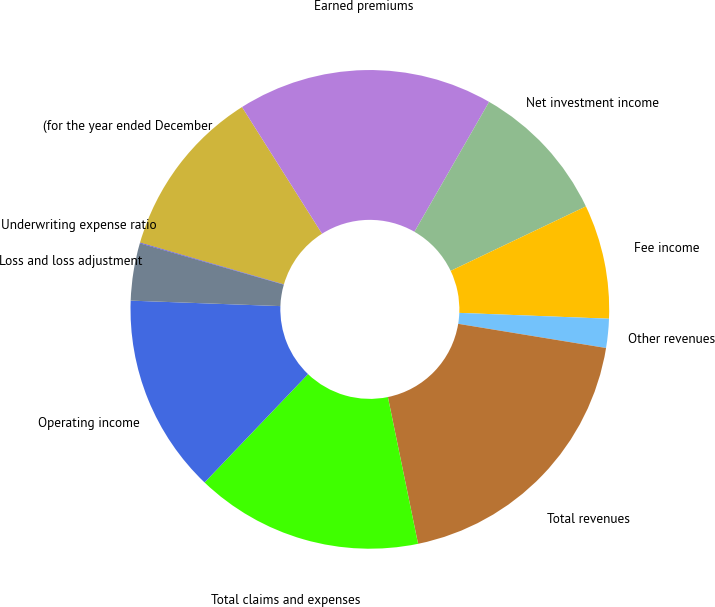<chart> <loc_0><loc_0><loc_500><loc_500><pie_chart><fcel>(for the year ended December<fcel>Earned premiums<fcel>Net investment income<fcel>Fee income<fcel>Other revenues<fcel>Total revenues<fcel>Total claims and expenses<fcel>Operating income<fcel>Loss and loss adjustment<fcel>Underwriting expense ratio<nl><fcel>11.53%<fcel>17.27%<fcel>9.62%<fcel>7.7%<fcel>1.96%<fcel>19.19%<fcel>15.36%<fcel>13.45%<fcel>3.87%<fcel>0.05%<nl></chart> 